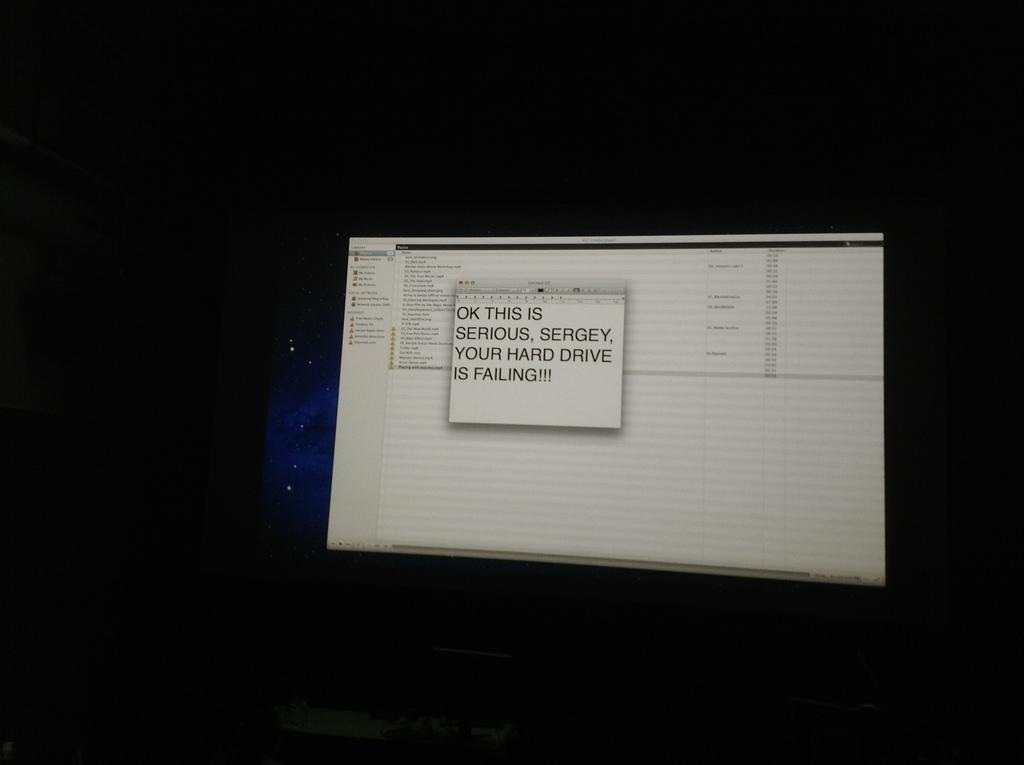<image>
Provide a brief description of the given image. Sergey's has a serious problem, their hard drive is failing. 